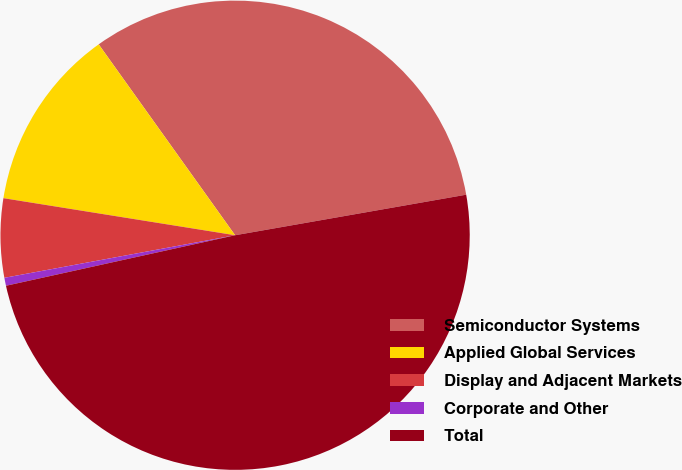Convert chart to OTSL. <chart><loc_0><loc_0><loc_500><loc_500><pie_chart><fcel>Semiconductor Systems<fcel>Applied Global Services<fcel>Display and Adjacent Markets<fcel>Corporate and Other<fcel>Total<nl><fcel>32.11%<fcel>12.6%<fcel>5.43%<fcel>0.55%<fcel>49.31%<nl></chart> 